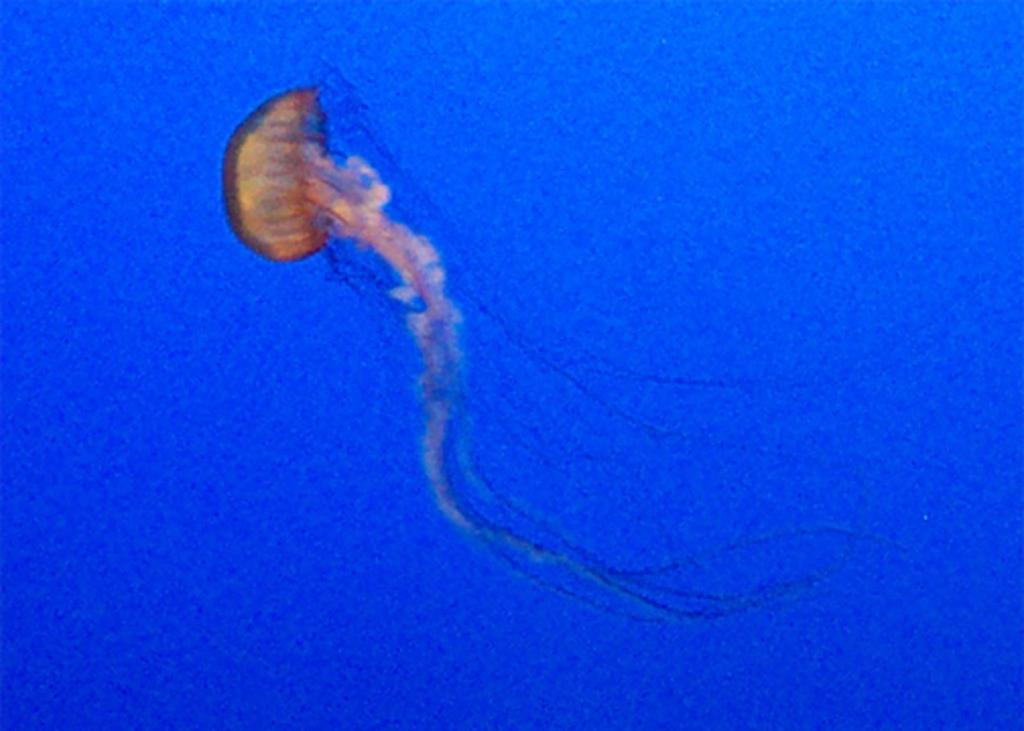Where was the image taken? The image was taken in the sea. What can be seen in the water in the middle of the image? There is a jellyfish in the water in the middle of the image. What type of square object can be seen in the image? There is no square object present in the image; it features a jellyfish in the sea. Is there a boy visible in the image? No, there is no boy present in the image. 